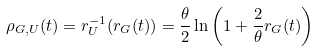Convert formula to latex. <formula><loc_0><loc_0><loc_500><loc_500>\rho _ { G , U } ( t ) = r _ { U } ^ { - 1 } ( r _ { G } ( t ) ) = \frac { \theta } { 2 } \ln \left ( 1 + \frac { 2 } { \theta } r _ { G } ( t ) \right )</formula> 